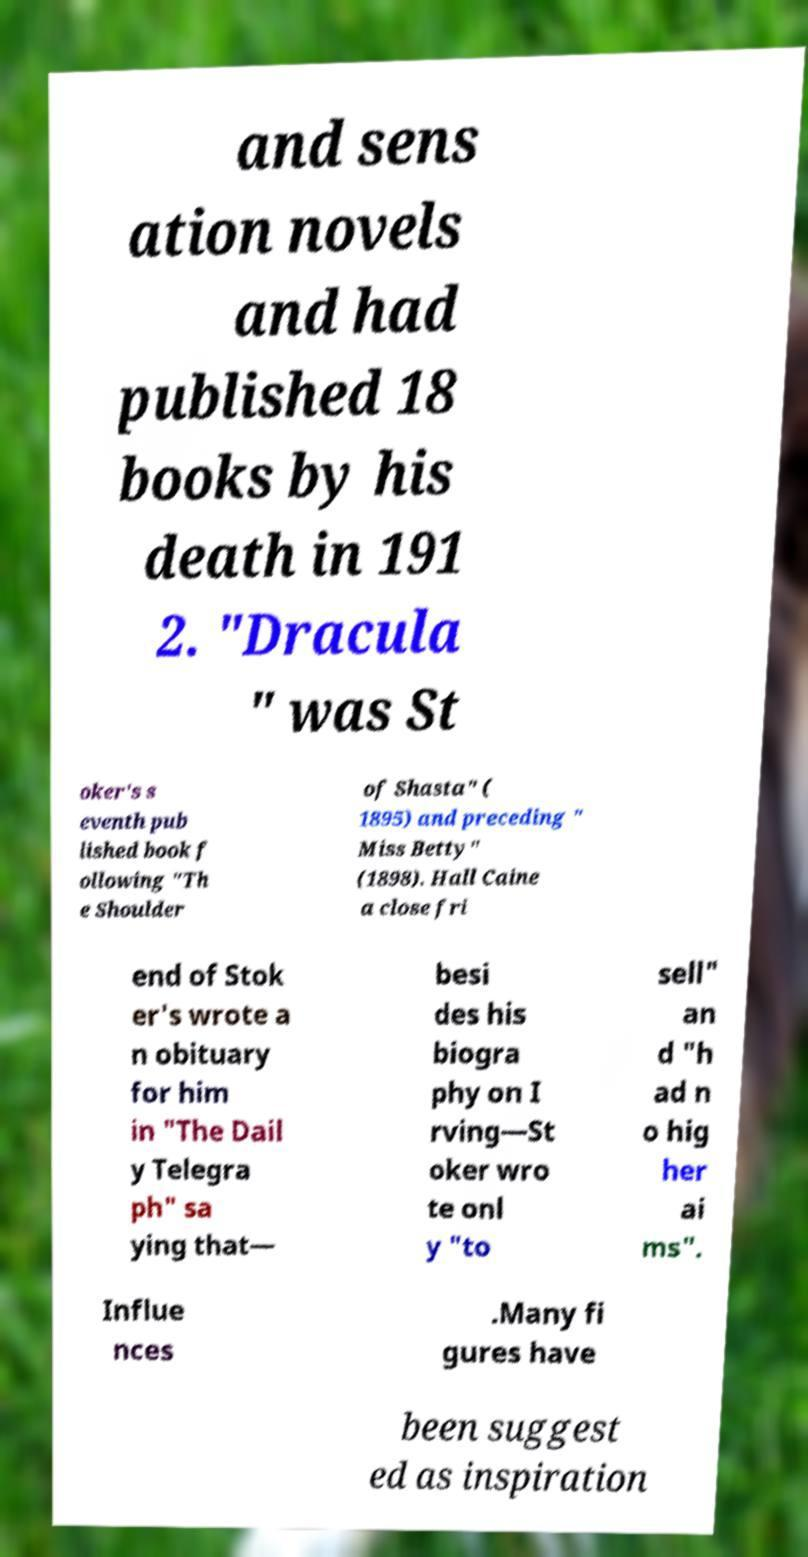Could you assist in decoding the text presented in this image and type it out clearly? and sens ation novels and had published 18 books by his death in 191 2. "Dracula " was St oker's s eventh pub lished book f ollowing "Th e Shoulder of Shasta" ( 1895) and preceding " Miss Betty" (1898). Hall Caine a close fri end of Stok er's wrote a n obituary for him in "The Dail y Telegra ph" sa ying that— besi des his biogra phy on I rving—St oker wro te onl y "to sell" an d "h ad n o hig her ai ms". Influe nces .Many fi gures have been suggest ed as inspiration 